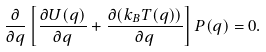<formula> <loc_0><loc_0><loc_500><loc_500>\frac { \partial } { \partial q } \left [ \frac { \partial U ( q ) } { \partial q } + \frac { \partial ( k _ { B } T ( q ) ) } { \partial q } \right ] P ( q ) = 0 .</formula> 